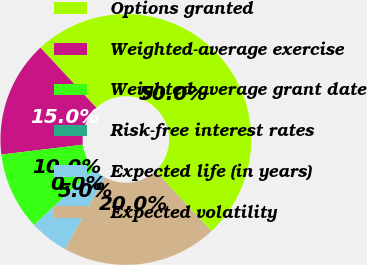Convert chart. <chart><loc_0><loc_0><loc_500><loc_500><pie_chart><fcel>Options granted<fcel>Weighted-average exercise<fcel>Weighted-average grant date<fcel>Risk-free interest rates<fcel>Expected life (in years)<fcel>Expected volatility<nl><fcel>49.98%<fcel>15.0%<fcel>10.0%<fcel>0.01%<fcel>5.01%<fcel>20.0%<nl></chart> 